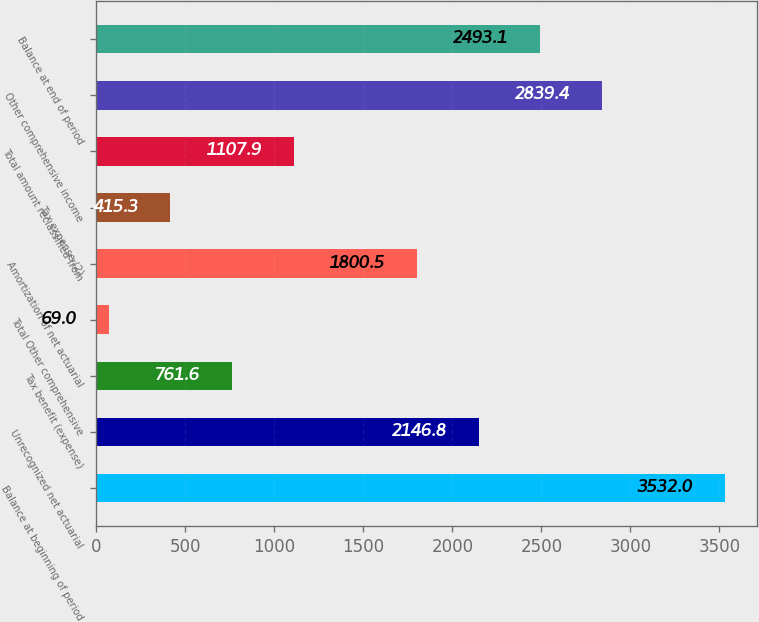<chart> <loc_0><loc_0><loc_500><loc_500><bar_chart><fcel>Balance at beginning of period<fcel>Unrecognized net actuarial<fcel>Tax benefit (expense)<fcel>Total Other comprehensive<fcel>Amortization of net actuarial<fcel>Tax expense (2)<fcel>Total amount reclassified from<fcel>Other comprehensive income<fcel>Balance at end of period<nl><fcel>3532<fcel>2146.8<fcel>761.6<fcel>69<fcel>1800.5<fcel>415.3<fcel>1107.9<fcel>2839.4<fcel>2493.1<nl></chart> 